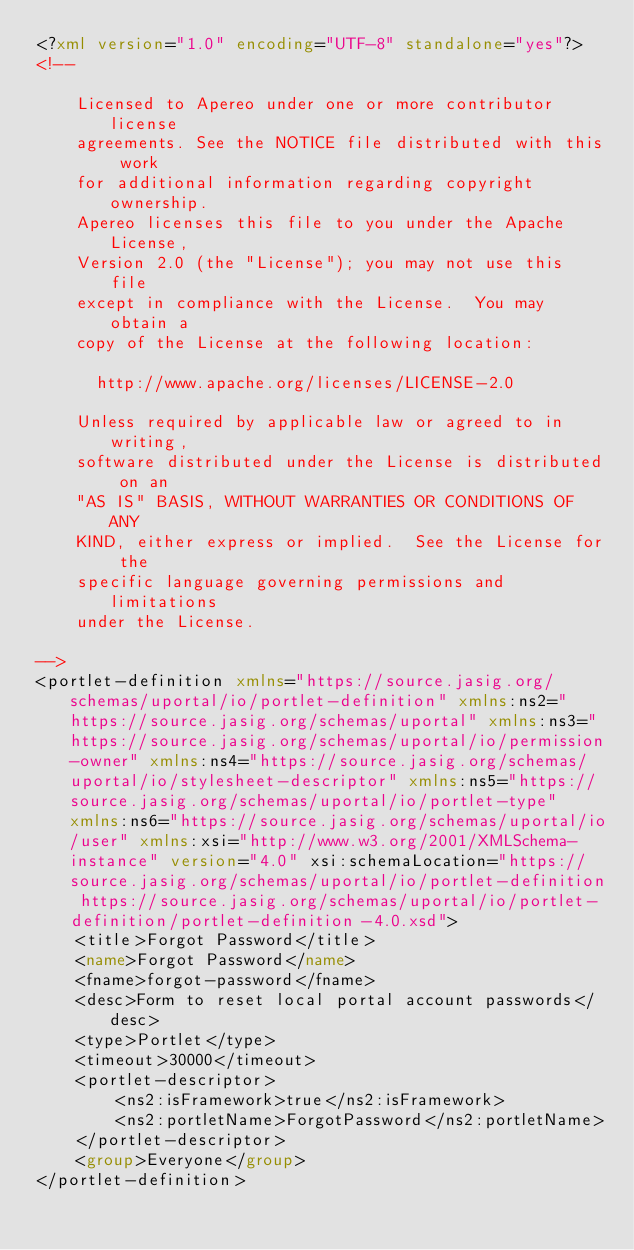Convert code to text. <code><loc_0><loc_0><loc_500><loc_500><_XML_><?xml version="1.0" encoding="UTF-8" standalone="yes"?>
<!--

    Licensed to Apereo under one or more contributor license
    agreements. See the NOTICE file distributed with this work
    for additional information regarding copyright ownership.
    Apereo licenses this file to you under the Apache License,
    Version 2.0 (the "License"); you may not use this file
    except in compliance with the License.  You may obtain a
    copy of the License at the following location:

      http://www.apache.org/licenses/LICENSE-2.0

    Unless required by applicable law or agreed to in writing,
    software distributed under the License is distributed on an
    "AS IS" BASIS, WITHOUT WARRANTIES OR CONDITIONS OF ANY
    KIND, either express or implied.  See the License for the
    specific language governing permissions and limitations
    under the License.

-->
<portlet-definition xmlns="https://source.jasig.org/schemas/uportal/io/portlet-definition" xmlns:ns2="https://source.jasig.org/schemas/uportal" xmlns:ns3="https://source.jasig.org/schemas/uportal/io/permission-owner" xmlns:ns4="https://source.jasig.org/schemas/uportal/io/stylesheet-descriptor" xmlns:ns5="https://source.jasig.org/schemas/uportal/io/portlet-type" xmlns:ns6="https://source.jasig.org/schemas/uportal/io/user" xmlns:xsi="http://www.w3.org/2001/XMLSchema-instance" version="4.0" xsi:schemaLocation="https://source.jasig.org/schemas/uportal/io/portlet-definition https://source.jasig.org/schemas/uportal/io/portlet-definition/portlet-definition-4.0.xsd">
    <title>Forgot Password</title>
    <name>Forgot Password</name>
    <fname>forgot-password</fname>
    <desc>Form to reset local portal account passwords</desc>
    <type>Portlet</type>
    <timeout>30000</timeout>
    <portlet-descriptor>
        <ns2:isFramework>true</ns2:isFramework>
        <ns2:portletName>ForgotPassword</ns2:portletName>
    </portlet-descriptor>
    <group>Everyone</group>
</portlet-definition>
</code> 